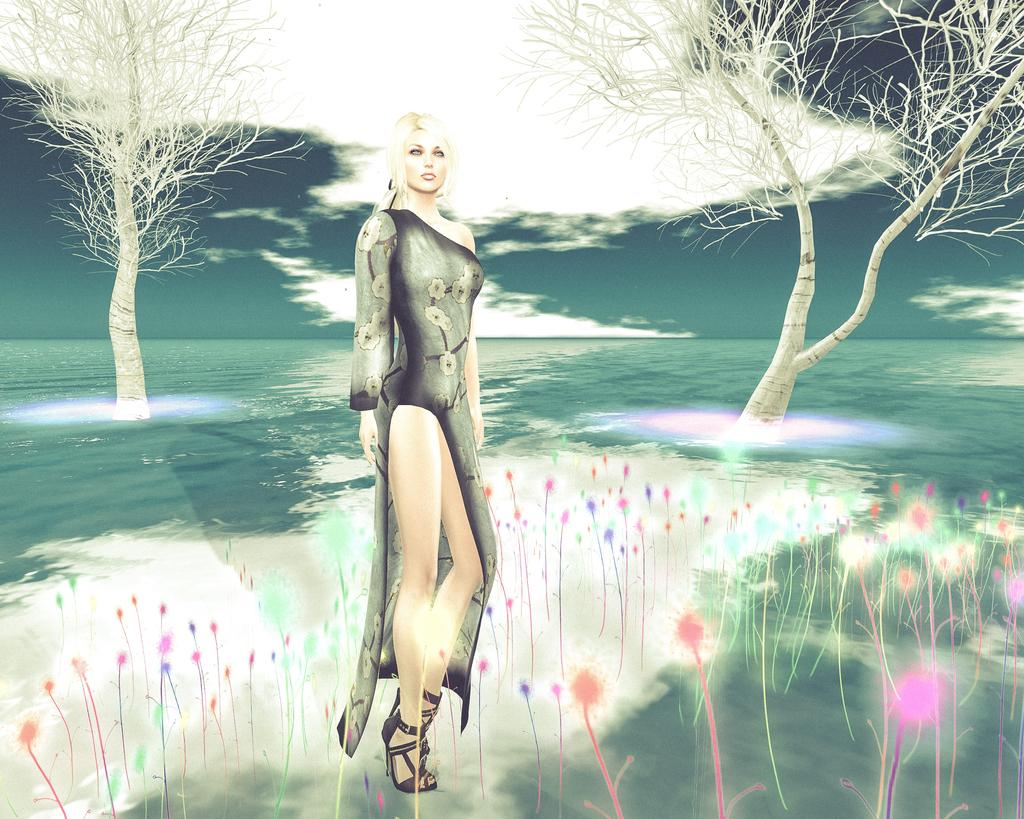What is depicted in the painting in the image? There is a painting of a woman in the image. What is the woman wearing in the painting? The woman is wearing a black dress in the painting. What natural elements can be seen in the image? There is water, trees, and the sky visible in the image. What is the condition of the sky in the image? The sky is visible in the image, and there are clouds present. What type of disease is affecting the trees in the image? There is no indication of any disease affecting the trees in the image; they appear to be healthy. How does the coastline look in the image? There is no coastline visible in the image; it features a painting of a woman, water, trees, and the sky. 